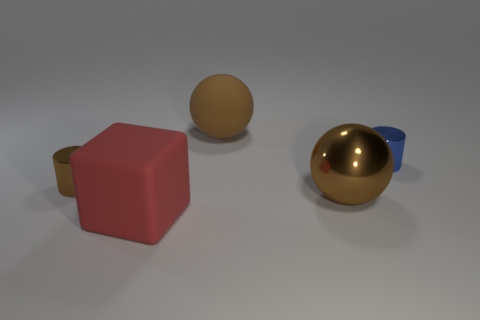What shape is the rubber object that is the same size as the red matte block?
Offer a very short reply. Sphere. Is there another metallic thing of the same shape as the big metallic object?
Your answer should be compact. No. What is the shape of the tiny thing that is on the left side of the tiny cylinder that is right of the red rubber thing?
Provide a short and direct response. Cylinder. The tiny brown thing is what shape?
Keep it short and to the point. Cylinder. What material is the big sphere that is in front of the large brown sphere that is behind the big brown ball in front of the small blue cylinder made of?
Your answer should be compact. Metal. What number of other things are the same material as the tiny blue cylinder?
Keep it short and to the point. 2. What number of large shiny objects are on the right side of the large rubber thing behind the red rubber thing?
Your response must be concise. 1. What number of cylinders are either tiny metallic things or small blue metal objects?
Give a very brief answer. 2. What is the color of the thing that is both in front of the tiny brown metal cylinder and behind the red rubber block?
Your answer should be very brief. Brown. Is there anything else that has the same color as the cube?
Provide a short and direct response. No. 